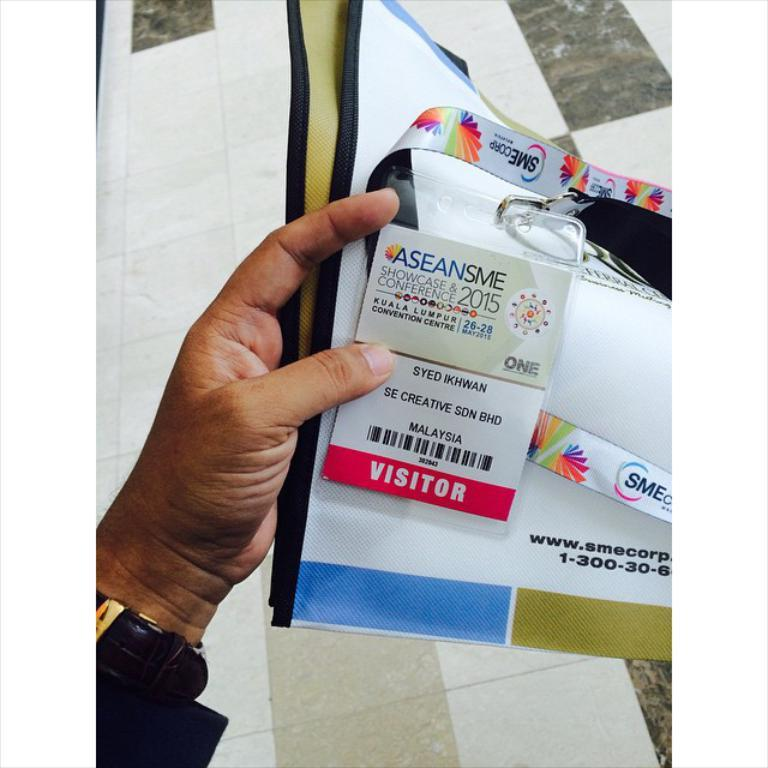What is the hand in the image holding? The hand is holding a watch and papers. Is there any additional object in the hand? Yes, there is a tag in the hand. What can be seen in the background of the image? There is a floor visible in the background of the image. What type of cushion is being used to support the brain in the image? There is no brain or cushion present in the image. 